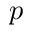<formula> <loc_0><loc_0><loc_500><loc_500>p</formula> 